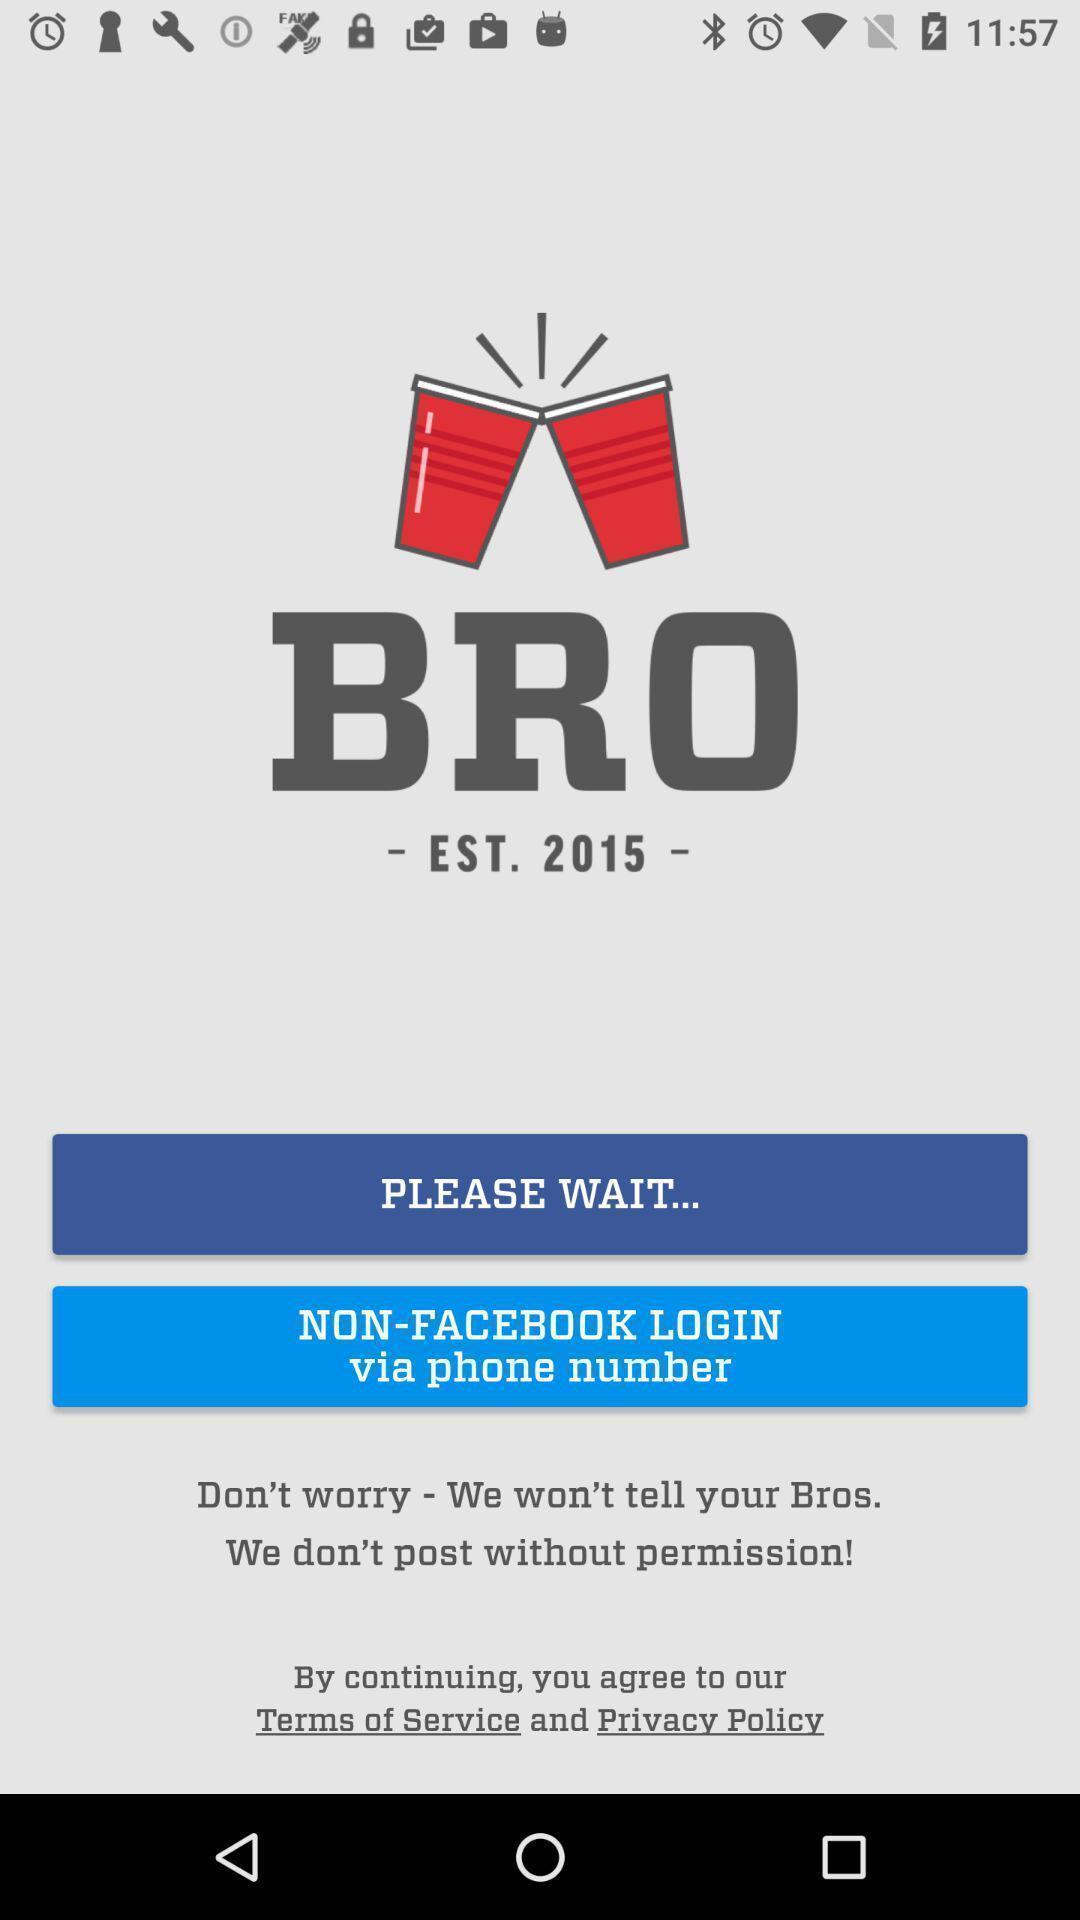Give me a summary of this screen capture. Welcome page. 